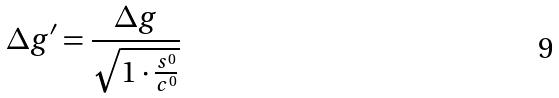Convert formula to latex. <formula><loc_0><loc_0><loc_500><loc_500>\Delta g ^ { \prime } = \frac { \Delta g } { \sqrt { 1 \cdot \frac { s ^ { 0 } } { c ^ { 0 } } } }</formula> 